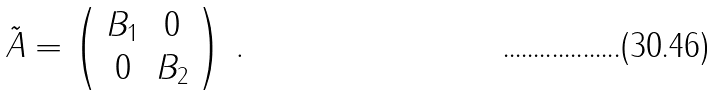<formula> <loc_0><loc_0><loc_500><loc_500>\tilde { A } = \left ( \begin{array} { c c } B _ { 1 } & 0 \\ 0 & B _ { 2 } \end{array} \right ) \, .</formula> 